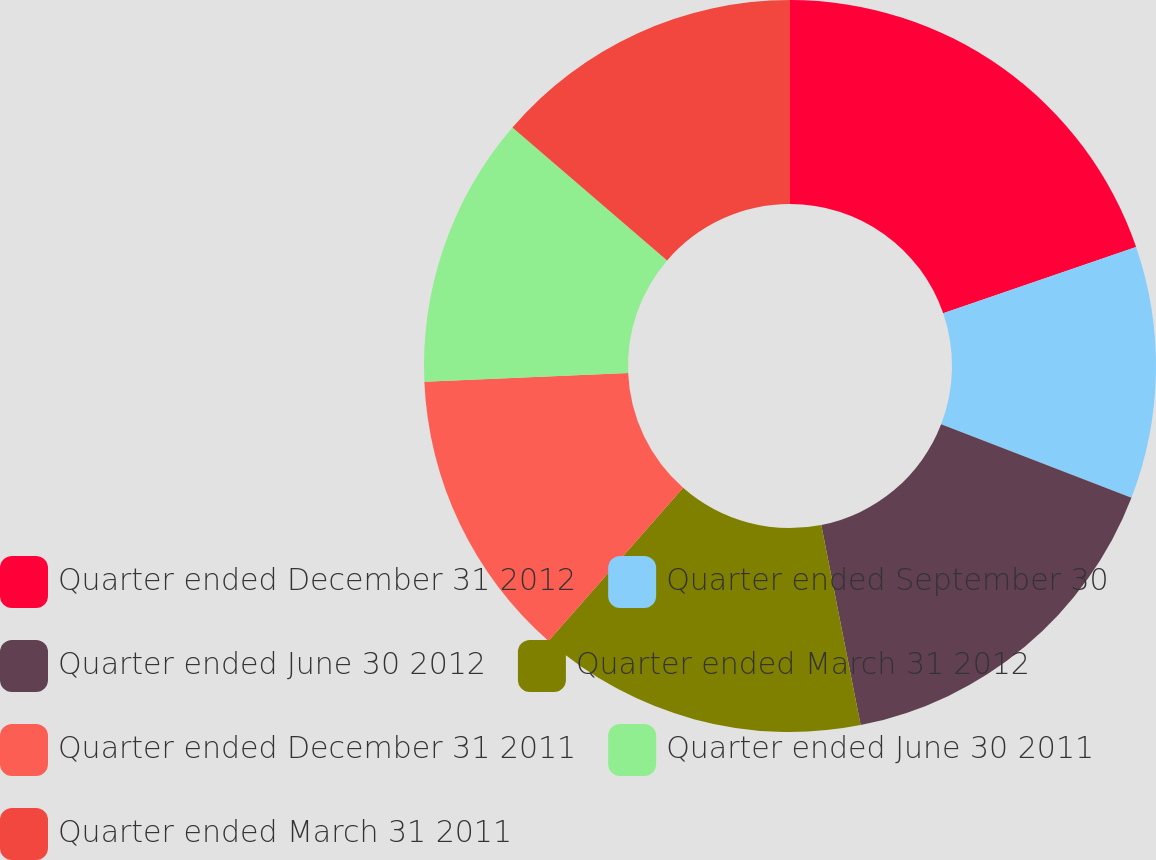<chart> <loc_0><loc_0><loc_500><loc_500><pie_chart><fcel>Quarter ended December 31 2012<fcel>Quarter ended September 30<fcel>Quarter ended June 30 2012<fcel>Quarter ended March 31 2012<fcel>Quarter ended December 31 2011<fcel>Quarter ended June 30 2011<fcel>Quarter ended March 31 2011<nl><fcel>19.73%<fcel>11.13%<fcel>16.05%<fcel>14.56%<fcel>12.84%<fcel>11.99%<fcel>13.7%<nl></chart> 